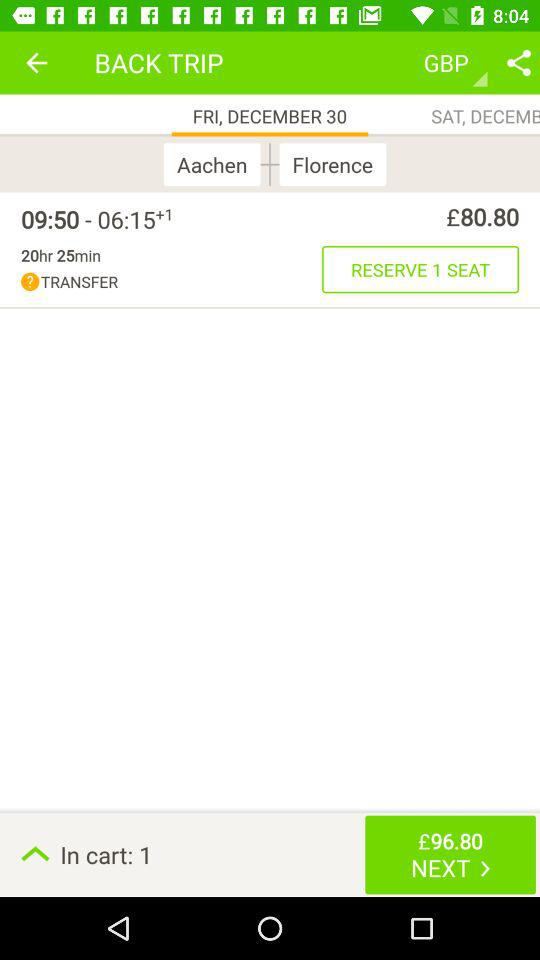Which flight takes place on Saturday?
When the provided information is insufficient, respond with <no answer>. <no answer> 